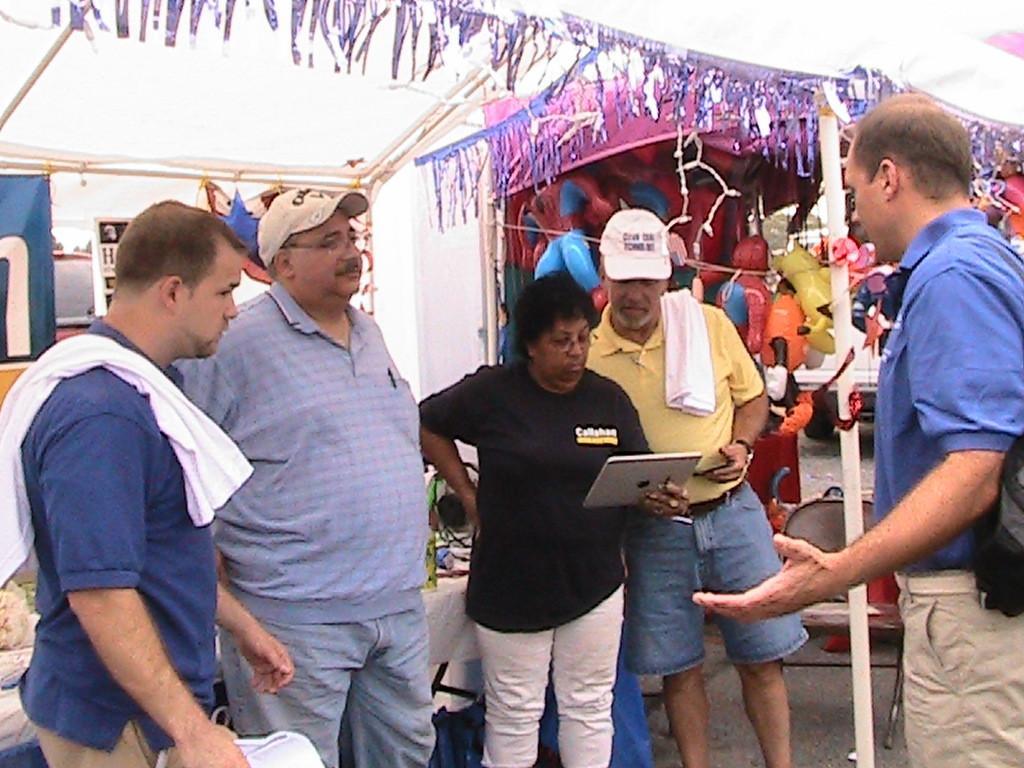How would you summarize this image in a sentence or two? There are many people standing. Some are wearing caps. Lady is holding a tab. In the back there are sheds. Inside the sheds there are toys. Also there are some decorations. 